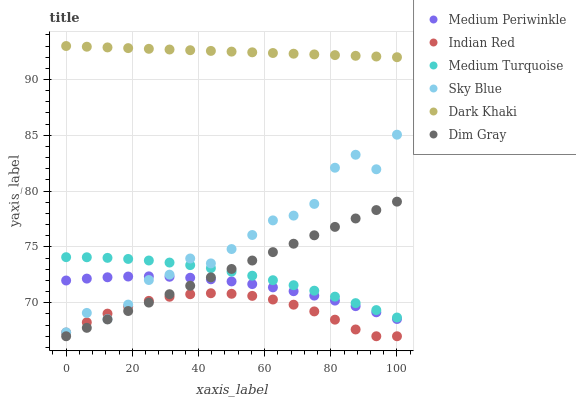Does Indian Red have the minimum area under the curve?
Answer yes or no. Yes. Does Dark Khaki have the maximum area under the curve?
Answer yes or no. Yes. Does Medium Periwinkle have the minimum area under the curve?
Answer yes or no. No. Does Medium Periwinkle have the maximum area under the curve?
Answer yes or no. No. Is Dim Gray the smoothest?
Answer yes or no. Yes. Is Sky Blue the roughest?
Answer yes or no. Yes. Is Indian Red the smoothest?
Answer yes or no. No. Is Indian Red the roughest?
Answer yes or no. No. Does Dim Gray have the lowest value?
Answer yes or no. Yes. Does Medium Periwinkle have the lowest value?
Answer yes or no. No. Does Dark Khaki have the highest value?
Answer yes or no. Yes. Does Medium Periwinkle have the highest value?
Answer yes or no. No. Is Medium Periwinkle less than Dark Khaki?
Answer yes or no. Yes. Is Sky Blue greater than Dim Gray?
Answer yes or no. Yes. Does Medium Periwinkle intersect Sky Blue?
Answer yes or no. Yes. Is Medium Periwinkle less than Sky Blue?
Answer yes or no. No. Is Medium Periwinkle greater than Sky Blue?
Answer yes or no. No. Does Medium Periwinkle intersect Dark Khaki?
Answer yes or no. No. 